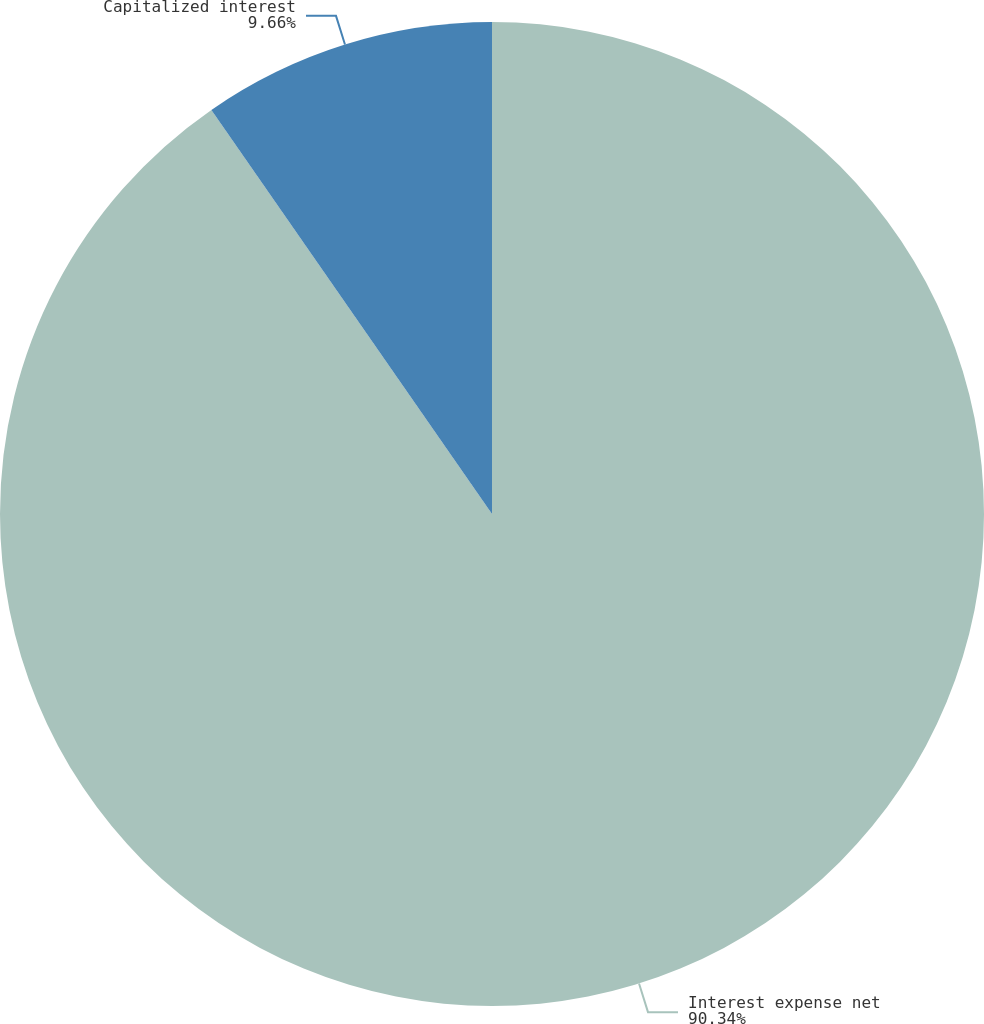<chart> <loc_0><loc_0><loc_500><loc_500><pie_chart><fcel>Interest expense net<fcel>Capitalized interest<nl><fcel>90.34%<fcel>9.66%<nl></chart> 